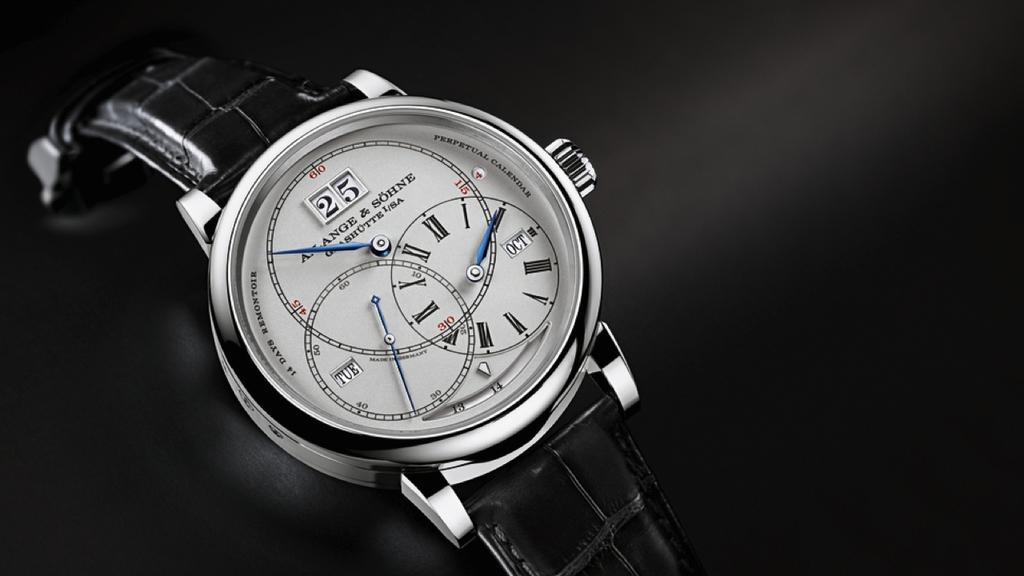<image>
Describe the image concisely. A watch by A. Lange & Sohne features a black band. 